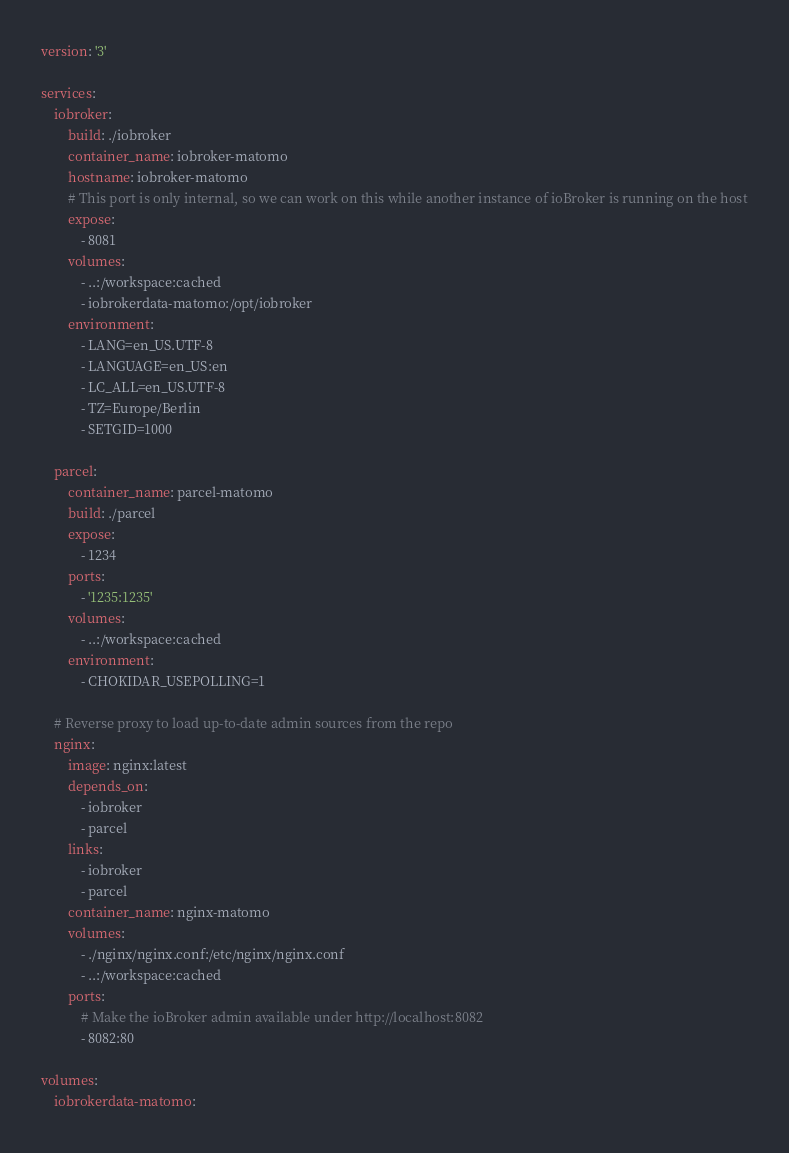<code> <loc_0><loc_0><loc_500><loc_500><_YAML_>version: '3'

services:
    iobroker:
        build: ./iobroker
        container_name: iobroker-matomo
        hostname: iobroker-matomo
        # This port is only internal, so we can work on this while another instance of ioBroker is running on the host
        expose:
            - 8081
        volumes:
            - ..:/workspace:cached
            - iobrokerdata-matomo:/opt/iobroker
        environment:
            - LANG=en_US.UTF-8
            - LANGUAGE=en_US:en
            - LC_ALL=en_US.UTF-8
            - TZ=Europe/Berlin
            - SETGID=1000

    parcel:
        container_name: parcel-matomo
        build: ./parcel
        expose:
            - 1234
        ports:
            - '1235:1235'
        volumes:
            - ..:/workspace:cached
        environment:
            - CHOKIDAR_USEPOLLING=1

    # Reverse proxy to load up-to-date admin sources from the repo
    nginx:
        image: nginx:latest
        depends_on:
            - iobroker
            - parcel
        links:
            - iobroker
            - parcel
        container_name: nginx-matomo
        volumes:
            - ./nginx/nginx.conf:/etc/nginx/nginx.conf
            - ..:/workspace:cached
        ports:
            # Make the ioBroker admin available under http://localhost:8082
            - 8082:80

volumes:
    iobrokerdata-matomo:</code> 